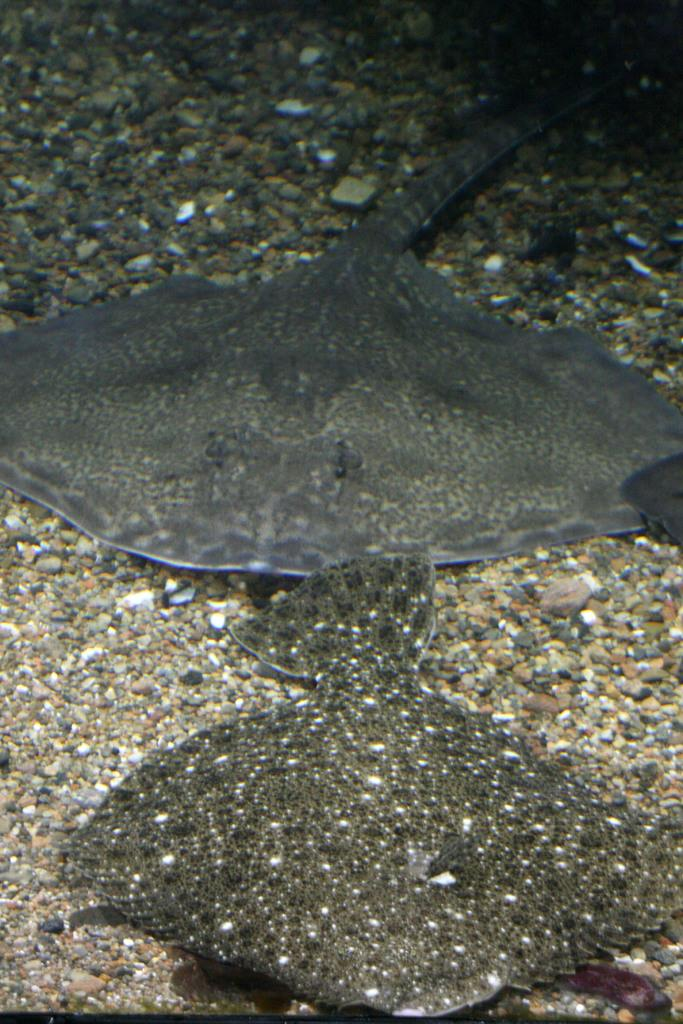What type of animals can be seen in the image? There are fishes in the image. What other objects are present in the image besides the fishes? There are stones in the image. Can you describe any other objects in the image? There are other unspecified objects in the image. What is the price of the oven in the image? There is no oven present in the image, so it is not possible to determine its price. 